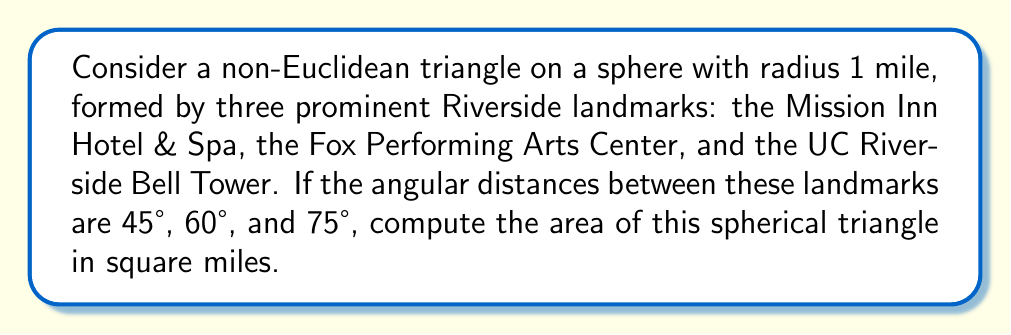Solve this math problem. To solve this problem, we'll use the formula for the area of a spherical triangle:

$$A = R^2(α + β + γ - π)$$

Where:
- $A$ is the area of the spherical triangle
- $R$ is the radius of the sphere
- $α$, $β$, and $γ$ are the angles of the spherical triangle in radians

Step 1: Convert the given angles from degrees to radians:
$α = 45° = \frac{π}{4}$ radians
$β = 60° = \frac{π}{3}$ radians
$γ = 75° = \frac{5π}{12}$ radians

Step 2: Sum the angles:
$$α + β + γ = \frac{π}{4} + \frac{π}{3} + \frac{5π}{12} = \frac{3π}{12} + \frac{4π}{12} + \frac{5π}{12} = \frac{12π}{12} = π$$

Step 3: Substitute the values into the formula:
$$A = R^2(α + β + γ - π) = 1^2(π - π) = 0$$

Step 4: Interpret the result:
The area of the spherical triangle is 0 square miles. This makes sense because the sum of the angles in a spherical triangle must be greater than π (180°) for it to have a non-zero area. In this case, the sum of the angles is exactly π, which corresponds to a degenerate triangle with no area.

[asy]
import geometry;

unitsize(1cm);

pair A = (0,0);
pair B = (4,0);
pair C = (2,3);

draw(A--B--C--cycle);
draw(arc(A,0.5,0,45), Arrow);
draw(arc(B,0.5,180-60,180), Arrow);
draw(arc(C,0.5,-75,0), Arrow);

label("45°", A, SW);
label("60°", B, SE);
label("75°", C, N);

label("Mission Inn", A, S);
label("Fox Center", B, S);
label("UCR Bell Tower", C, N);
[/asy]
Answer: 0 square miles 